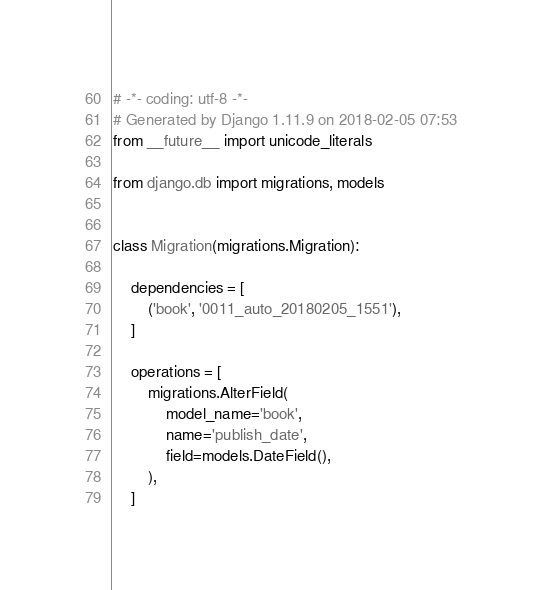<code> <loc_0><loc_0><loc_500><loc_500><_Python_># -*- coding: utf-8 -*-
# Generated by Django 1.11.9 on 2018-02-05 07:53
from __future__ import unicode_literals

from django.db import migrations, models


class Migration(migrations.Migration):

    dependencies = [
        ('book', '0011_auto_20180205_1551'),
    ]

    operations = [
        migrations.AlterField(
            model_name='book',
            name='publish_date',
            field=models.DateField(),
        ),
    ]
</code> 